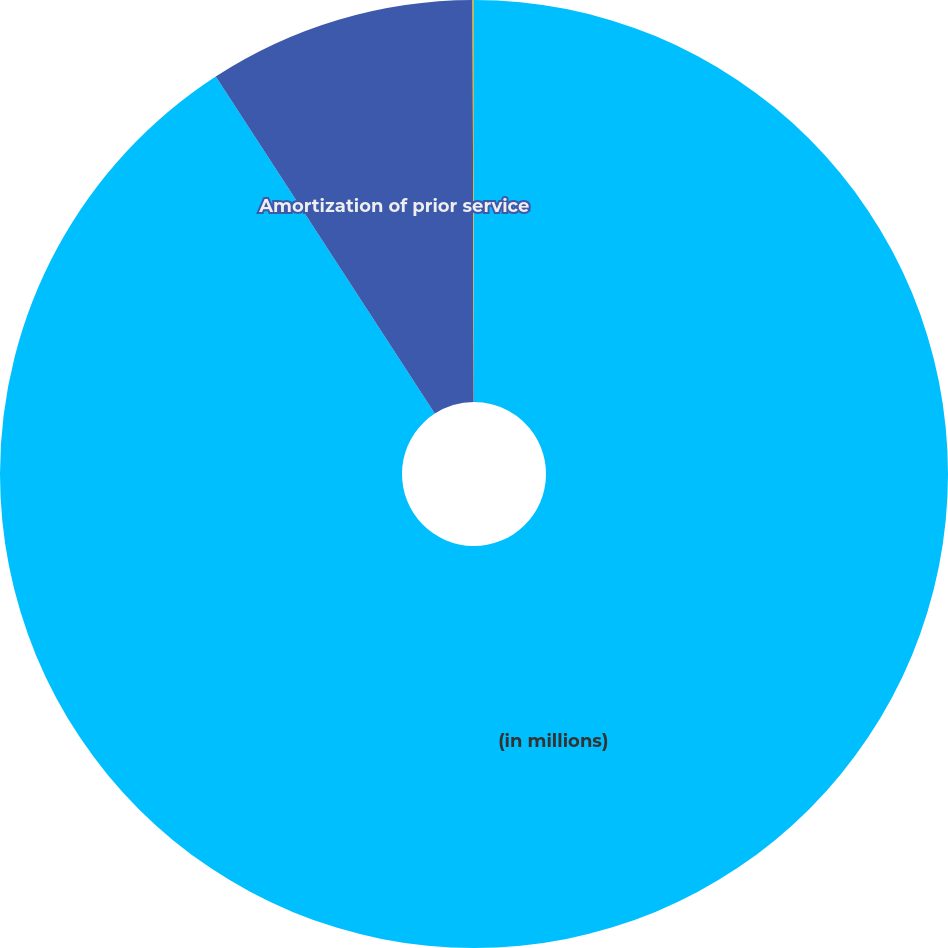Convert chart to OTSL. <chart><loc_0><loc_0><loc_500><loc_500><pie_chart><fcel>(in millions)<fcel>Amortization of prior service<fcel>Amortization of net loss<nl><fcel>90.83%<fcel>9.12%<fcel>0.05%<nl></chart> 